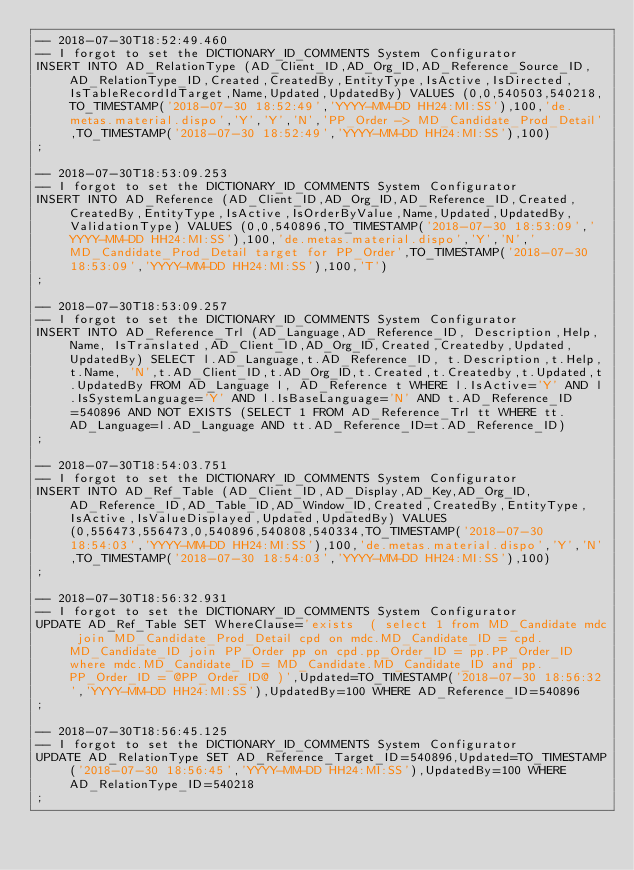<code> <loc_0><loc_0><loc_500><loc_500><_SQL_>-- 2018-07-30T18:52:49.460
-- I forgot to set the DICTIONARY_ID_COMMENTS System Configurator
INSERT INTO AD_RelationType (AD_Client_ID,AD_Org_ID,AD_Reference_Source_ID,AD_RelationType_ID,Created,CreatedBy,EntityType,IsActive,IsDirected,IsTableRecordIdTarget,Name,Updated,UpdatedBy) VALUES (0,0,540503,540218,TO_TIMESTAMP('2018-07-30 18:52:49','YYYY-MM-DD HH24:MI:SS'),100,'de.metas.material.dispo','Y','Y','N','PP_Order -> MD_Candidate_Prod_Detail',TO_TIMESTAMP('2018-07-30 18:52:49','YYYY-MM-DD HH24:MI:SS'),100)
;

-- 2018-07-30T18:53:09.253
-- I forgot to set the DICTIONARY_ID_COMMENTS System Configurator
INSERT INTO AD_Reference (AD_Client_ID,AD_Org_ID,AD_Reference_ID,Created,CreatedBy,EntityType,IsActive,IsOrderByValue,Name,Updated,UpdatedBy,ValidationType) VALUES (0,0,540896,TO_TIMESTAMP('2018-07-30 18:53:09','YYYY-MM-DD HH24:MI:SS'),100,'de.metas.material.dispo','Y','N','MD_Candidate_Prod_Detail target for PP_Order',TO_TIMESTAMP('2018-07-30 18:53:09','YYYY-MM-DD HH24:MI:SS'),100,'T')
;

-- 2018-07-30T18:53:09.257
-- I forgot to set the DICTIONARY_ID_COMMENTS System Configurator
INSERT INTO AD_Reference_Trl (AD_Language,AD_Reference_ID, Description,Help,Name, IsTranslated,AD_Client_ID,AD_Org_ID,Created,Createdby,Updated,UpdatedBy) SELECT l.AD_Language,t.AD_Reference_ID, t.Description,t.Help,t.Name, 'N',t.AD_Client_ID,t.AD_Org_ID,t.Created,t.Createdby,t.Updated,t.UpdatedBy FROM AD_Language l, AD_Reference t WHERE l.IsActive='Y' AND l.IsSystemLanguage='Y' AND l.IsBaseLanguage='N' AND t.AD_Reference_ID=540896 AND NOT EXISTS (SELECT 1 FROM AD_Reference_Trl tt WHERE tt.AD_Language=l.AD_Language AND tt.AD_Reference_ID=t.AD_Reference_ID)
;

-- 2018-07-30T18:54:03.751
-- I forgot to set the DICTIONARY_ID_COMMENTS System Configurator
INSERT INTO AD_Ref_Table (AD_Client_ID,AD_Display,AD_Key,AD_Org_ID,AD_Reference_ID,AD_Table_ID,AD_Window_ID,Created,CreatedBy,EntityType,IsActive,IsValueDisplayed,Updated,UpdatedBy) VALUES (0,556473,556473,0,540896,540808,540334,TO_TIMESTAMP('2018-07-30 18:54:03','YYYY-MM-DD HH24:MI:SS'),100,'de.metas.material.dispo','Y','N',TO_TIMESTAMP('2018-07-30 18:54:03','YYYY-MM-DD HH24:MI:SS'),100)
;

-- 2018-07-30T18:56:32.931
-- I forgot to set the DICTIONARY_ID_COMMENTS System Configurator
UPDATE AD_Ref_Table SET WhereClause='exists  ( select 1 from MD_Candidate mdc join MD_Candidate_Prod_Detail cpd on mdc.MD_Candidate_ID = cpd.MD_Candidate_ID join PP_Order pp on cpd.pp_Order_ID = pp.PP_Order_ID where mdc.MD_Candidate_ID = MD_Candidate.MD_Candidate_ID and pp.PP_Order_ID = @PP_Order_ID@ )',Updated=TO_TIMESTAMP('2018-07-30 18:56:32','YYYY-MM-DD HH24:MI:SS'),UpdatedBy=100 WHERE AD_Reference_ID=540896
;

-- 2018-07-30T18:56:45.125
-- I forgot to set the DICTIONARY_ID_COMMENTS System Configurator
UPDATE AD_RelationType SET AD_Reference_Target_ID=540896,Updated=TO_TIMESTAMP('2018-07-30 18:56:45','YYYY-MM-DD HH24:MI:SS'),UpdatedBy=100 WHERE AD_RelationType_ID=540218
;

</code> 